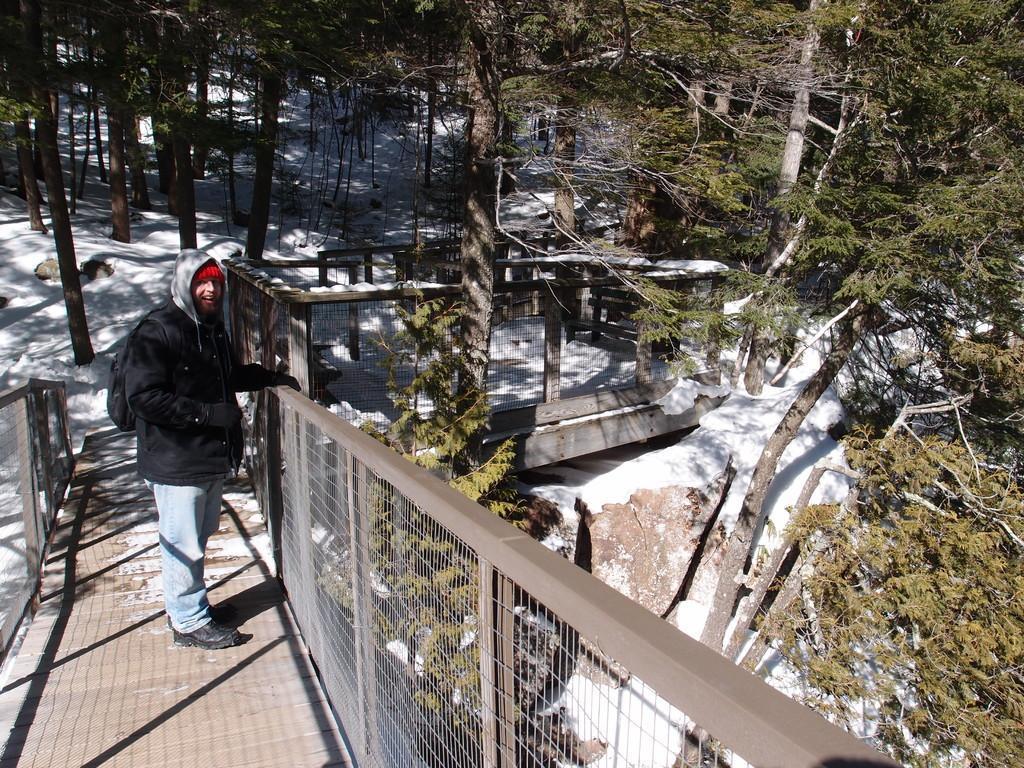In one or two sentences, can you explain what this image depicts? In this image, we can see some trees. There is a person on the left side of the image wearing clothes and standing on bridge. There is a cage in the middle of the image. 